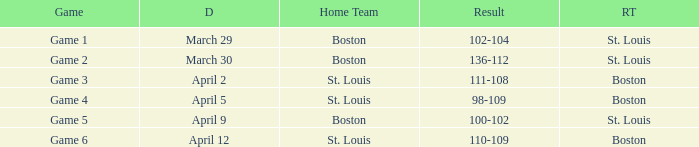On what Date is Game 3 with Boston Road Team? April 2. 